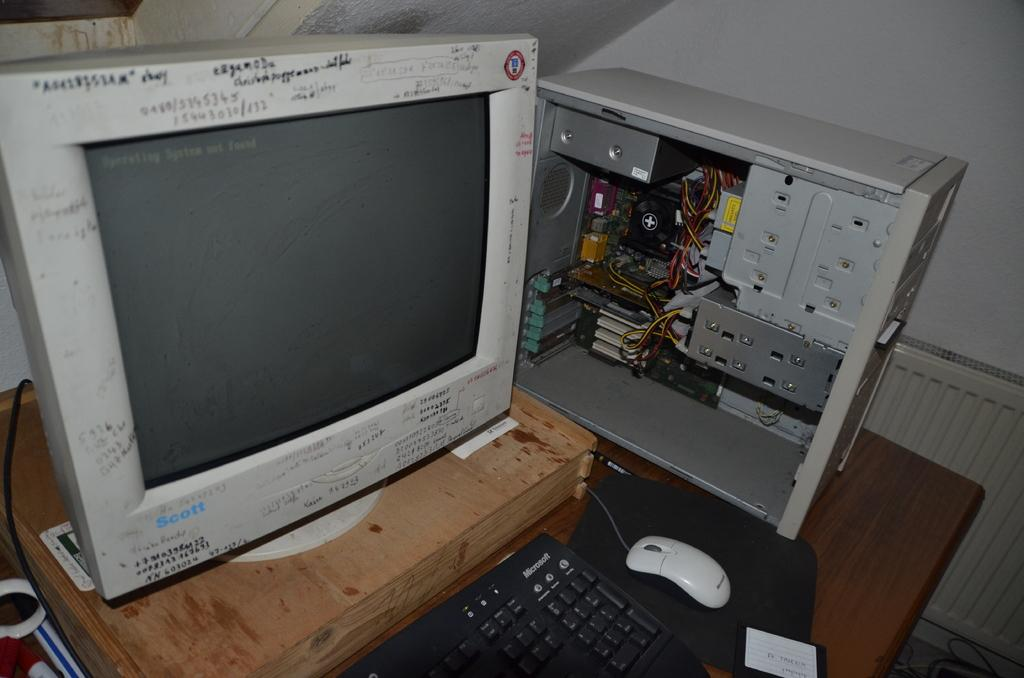<image>
Create a compact narrative representing the image presented. Old and broken desktop with a monitor from Scott. 